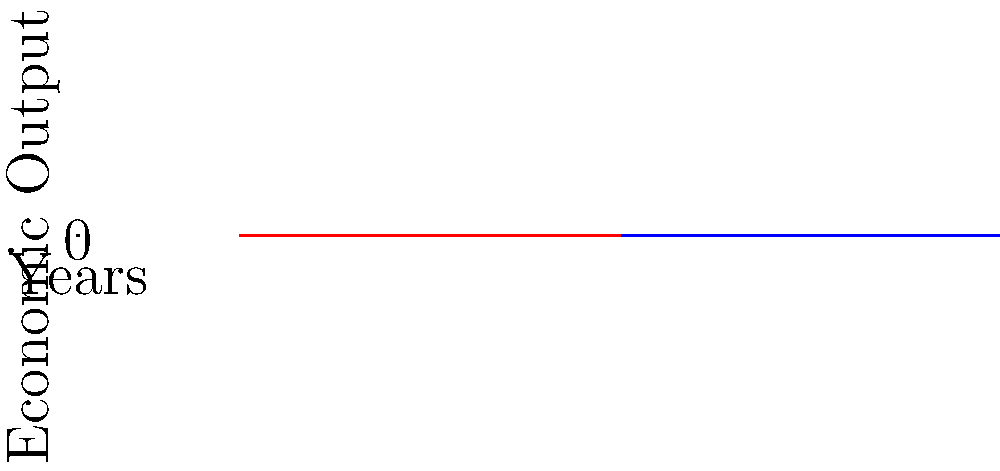Based on the line graph comparing economic output during peacetime and wartime over a 5-year period, what conclusion can be drawn about the long-term economic impact of war? To answer this question, let's analyze the graph step-by-step:

1. The blue line represents economic output during peacetime, while the red line represents wartime.

2. Peacetime trend:
   - Starts at 100 units
   - Shows a steady increase over the 5-year period
   - Ends at approximately 170 units

3. Wartime trend:
   - Also starts at 100 units
   - Shows a consistent decline over the 5-year period
   - Ends at approximately 30 units

4. Comparing the two trends:
   - Peacetime economy grows by about 70% over 5 years
   - Wartime economy shrinks by about 70% over 5 years

5. Long-term impact:
   - Peacetime allows for sustained economic growth
   - Wartime leads to significant economic decline

6. Conclusion:
   The graph clearly illustrates that war has a severely negative long-term impact on the economy, while peace fosters economic growth and prosperity.

This analysis aligns with the perspective of a civilian who understands the true cost of war beyond just the immediate conflict, emphasizing the importance of peaceful resolutions for long-term economic well-being.
Answer: War severely hinders economic growth, while peace promotes prosperity. 